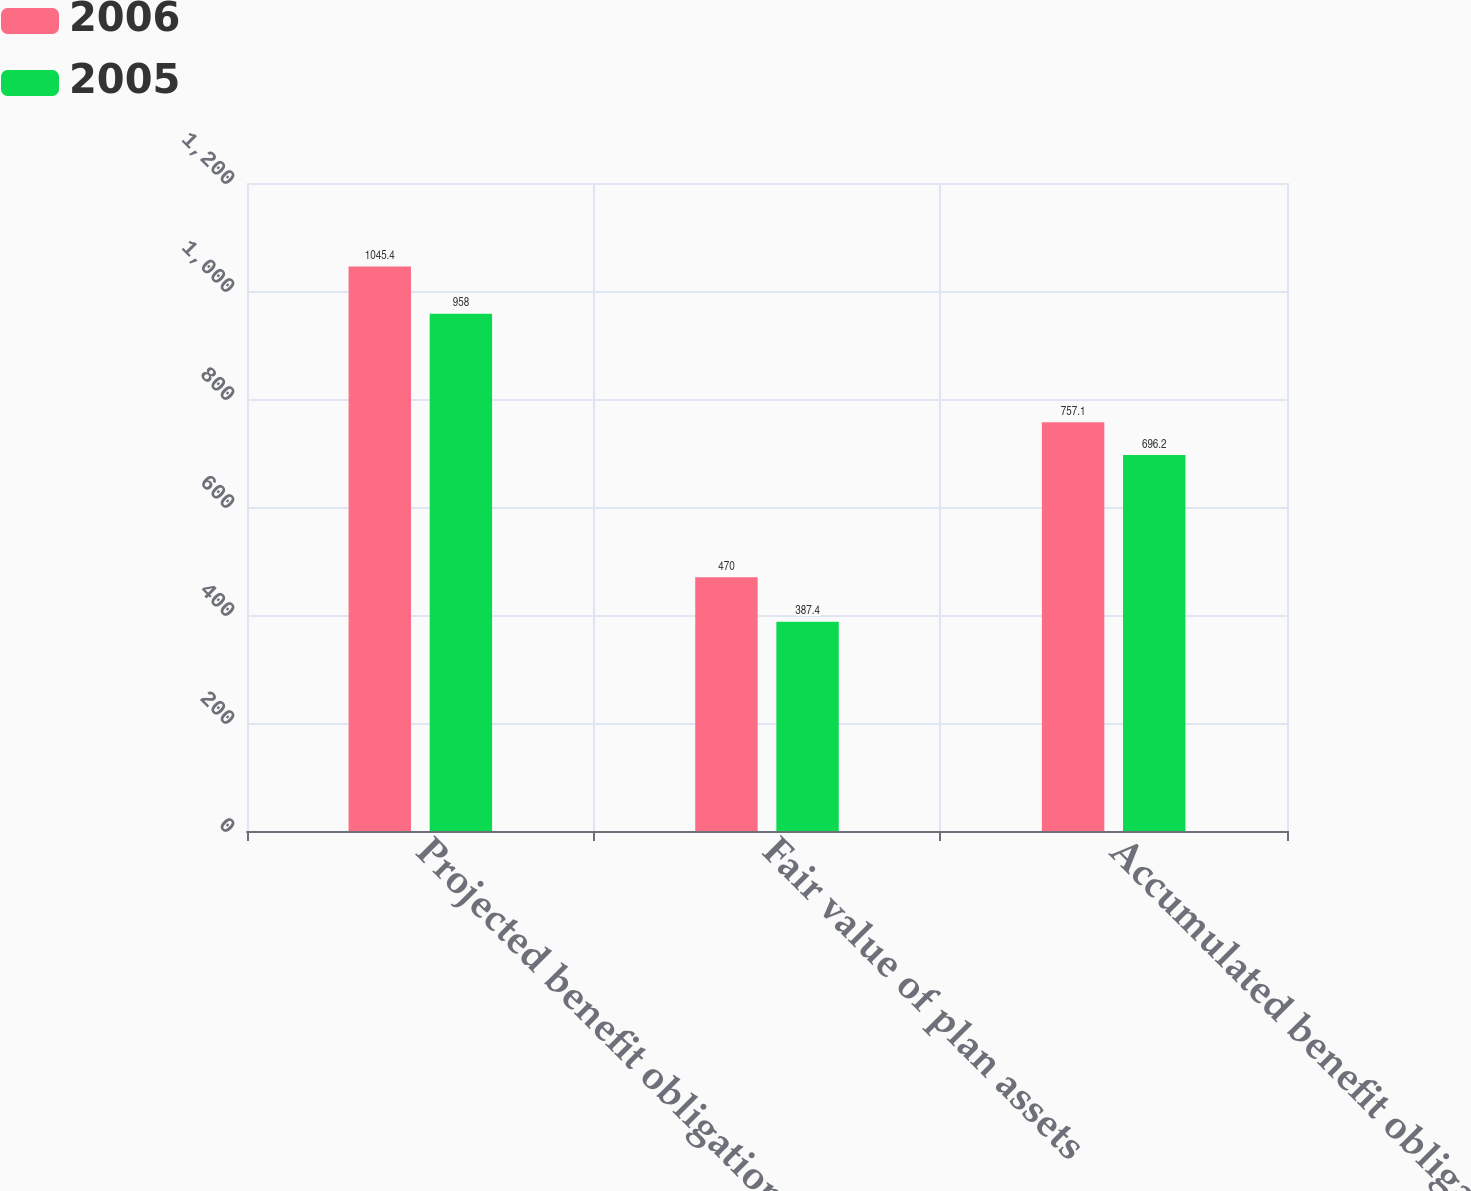Convert chart to OTSL. <chart><loc_0><loc_0><loc_500><loc_500><stacked_bar_chart><ecel><fcel>Projected benefit obligation<fcel>Fair value of plan assets<fcel>Accumulated benefit obligation<nl><fcel>2006<fcel>1045.4<fcel>470<fcel>757.1<nl><fcel>2005<fcel>958<fcel>387.4<fcel>696.2<nl></chart> 